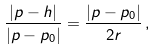<formula> <loc_0><loc_0><loc_500><loc_500>\frac { | p - h | } { | p - p _ { 0 } | } = \frac { | p - p _ { 0 } | } { 2 r } \, ,</formula> 